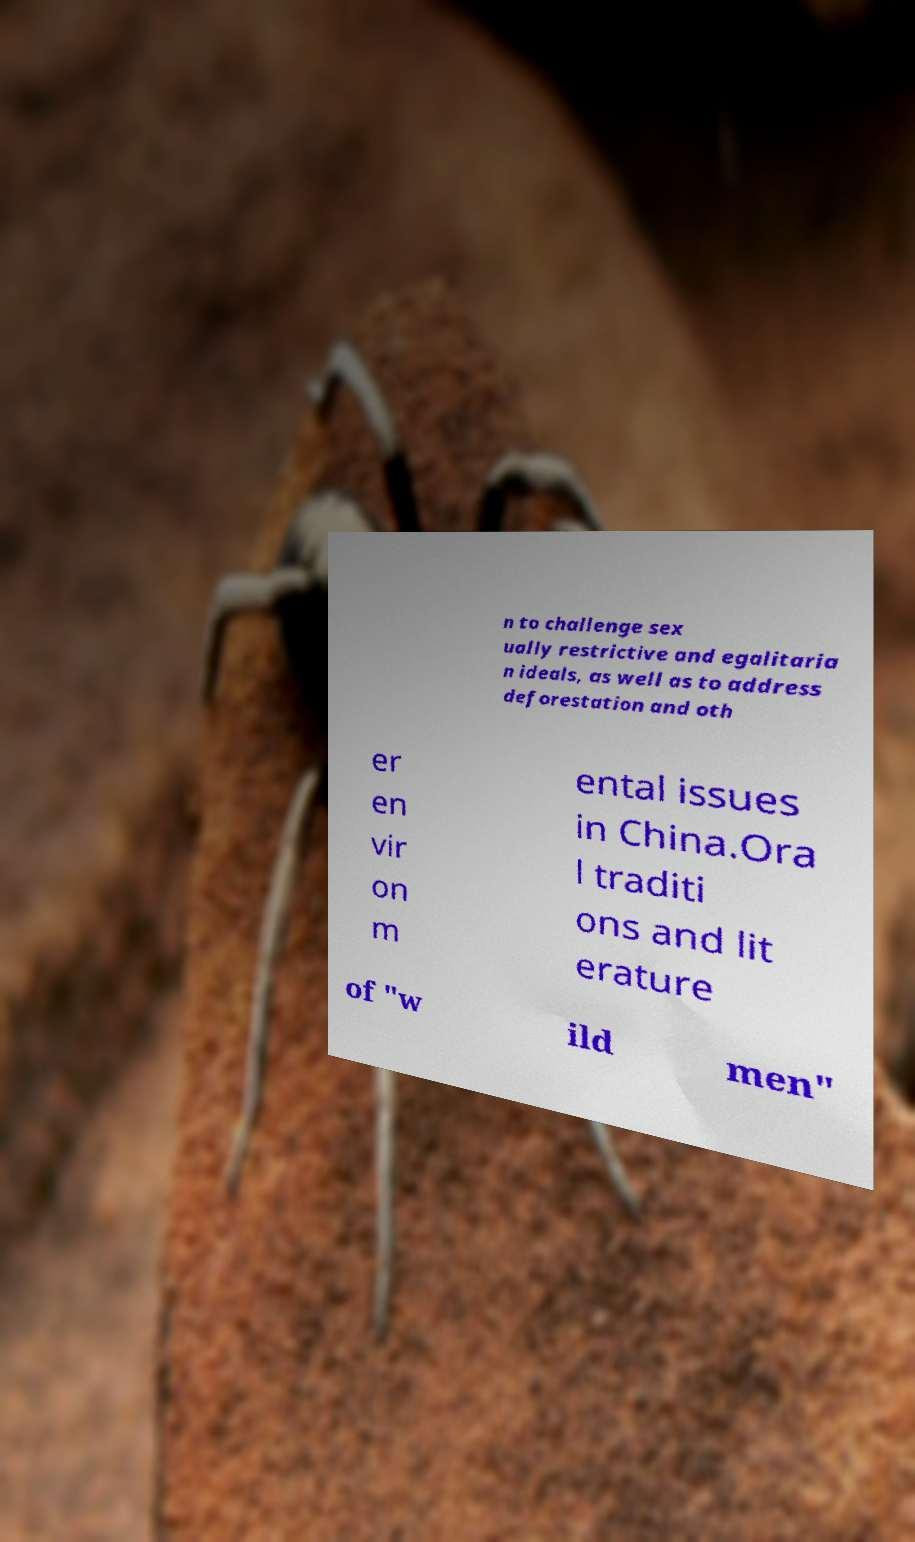Please read and relay the text visible in this image. What does it say? n to challenge sex ually restrictive and egalitaria n ideals, as well as to address deforestation and oth er en vir on m ental issues in China.Ora l traditi ons and lit erature of "w ild men" 